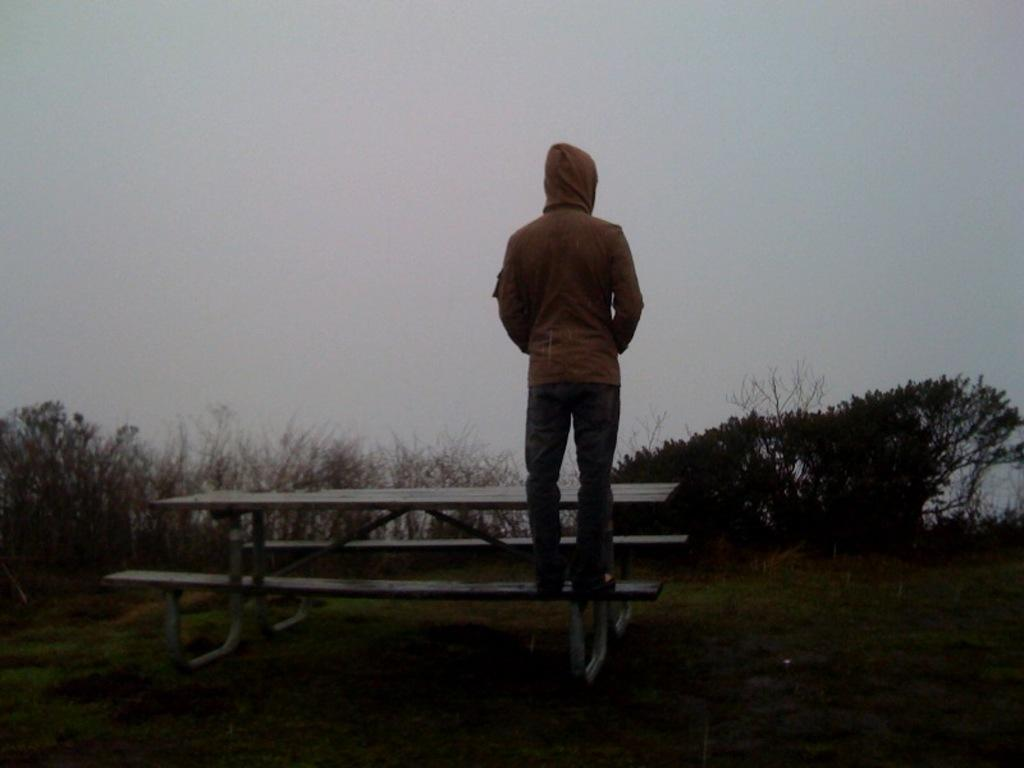What is the man in the image doing? The man is standing on a bench in the image. What type of surface is visible beneath the man's feet? There is grass visible in the image. What can be seen in the background of the image? There is a group of trees and the sky visible in the image. What type of distribution system is visible in the image? There is no distribution system present in the image. What can be said about the man's teeth in the image? The image does not show the man's teeth, so it cannot be determined what they look like or their condition. 